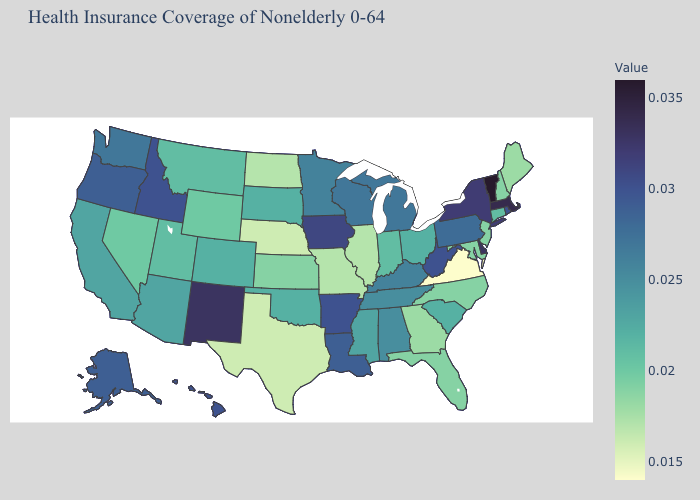Does Hawaii have a lower value than Florida?
Answer briefly. No. Among the states that border South Dakota , which have the lowest value?
Be succinct. Nebraska. Which states hav the highest value in the Northeast?
Short answer required. Vermont. Which states have the lowest value in the South?
Answer briefly. Virginia. 